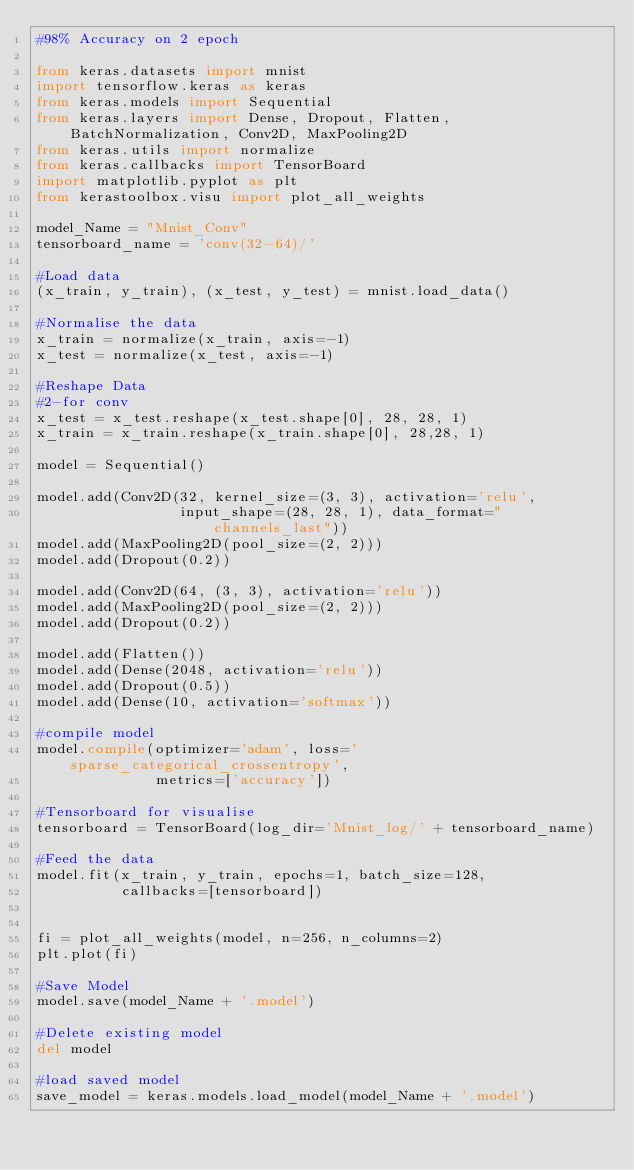<code> <loc_0><loc_0><loc_500><loc_500><_Python_>#98% Accuracy on 2 epoch

from keras.datasets import mnist
import tensorflow.keras as keras
from keras.models import Sequential
from keras.layers import Dense, Dropout, Flatten, BatchNormalization, Conv2D, MaxPooling2D
from keras.utils import normalize
from keras.callbacks import TensorBoard
import matplotlib.pyplot as plt
from kerastoolbox.visu import plot_all_weights

model_Name = "Mnist_Conv"
tensorboard_name = 'conv(32-64)/'

#Load data
(x_train, y_train), (x_test, y_test) = mnist.load_data()

#Normalise the data
x_train = normalize(x_train, axis=-1)
x_test = normalize(x_test, axis=-1)

#Reshape Data
#2-for conv
x_test = x_test.reshape(x_test.shape[0], 28, 28, 1)
x_train = x_train.reshape(x_train.shape[0], 28,28, 1)

model = Sequential()

model.add(Conv2D(32, kernel_size=(3, 3), activation='relu',
                 input_shape=(28, 28, 1), data_format="channels_last"))
model.add(MaxPooling2D(pool_size=(2, 2)))
model.add(Dropout(0.2))

model.add(Conv2D(64, (3, 3), activation='relu'))
model.add(MaxPooling2D(pool_size=(2, 2)))
model.add(Dropout(0.2))

model.add(Flatten())
model.add(Dense(2048, activation='relu'))
model.add(Dropout(0.5))
model.add(Dense(10, activation='softmax'))

#compile model
model.compile(optimizer='adam', loss='sparse_categorical_crossentropy',
              metrics=['accuracy'])

#Tensorboard for visualise
tensorboard = TensorBoard(log_dir='Mnist_log/' + tensorboard_name)

#Feed the data
model.fit(x_train, y_train, epochs=1, batch_size=128,
          callbacks=[tensorboard])


fi = plot_all_weights(model, n=256, n_columns=2)
plt.plot(fi)

#Save Model
model.save(model_Name + '.model')

#Delete existing model
del model

#load saved model
save_model = keras.models.load_model(model_Name + '.model')


</code> 